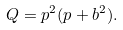Convert formula to latex. <formula><loc_0><loc_0><loc_500><loc_500>Q = p ^ { 2 } ( p + b ^ { 2 } ) .</formula> 